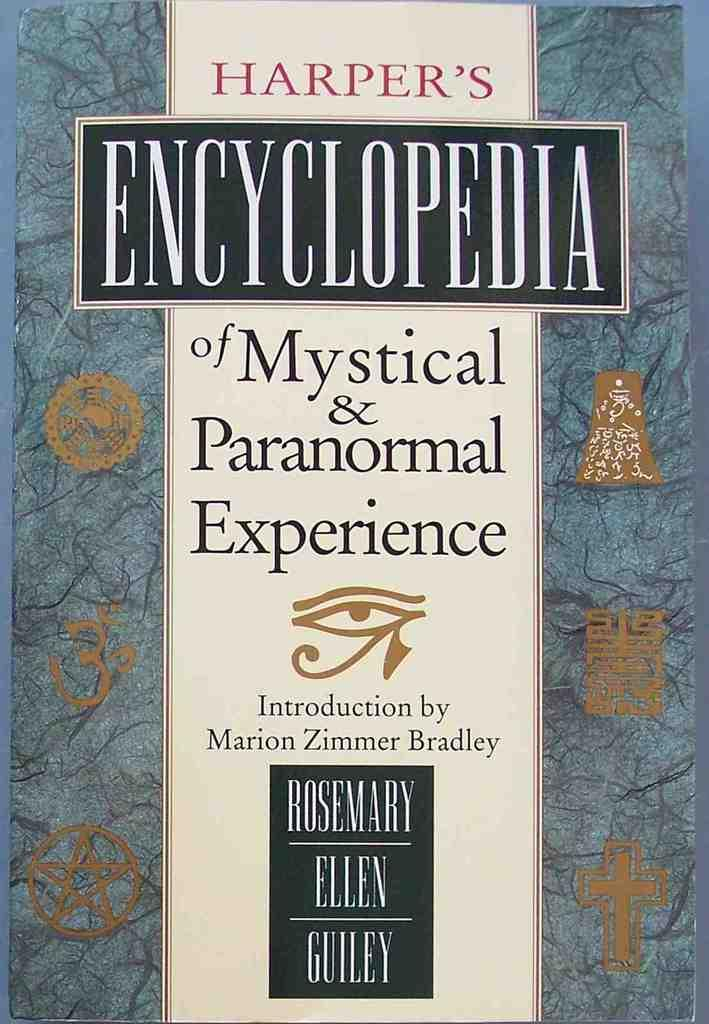<image>
Provide a brief description of the given image. A encyclopedia cover about mystical and paranormal experience. 